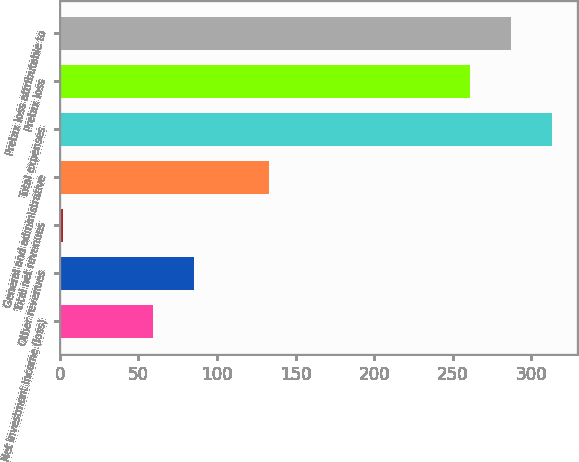<chart> <loc_0><loc_0><loc_500><loc_500><bar_chart><fcel>Net investment income (loss)<fcel>Other revenues<fcel>Total net revenues<fcel>General and administrative<fcel>Total expenses<fcel>Pretax loss<fcel>Pretax loss attributable to<nl><fcel>59<fcel>85.1<fcel>2<fcel>133<fcel>313.2<fcel>261<fcel>287.1<nl></chart> 